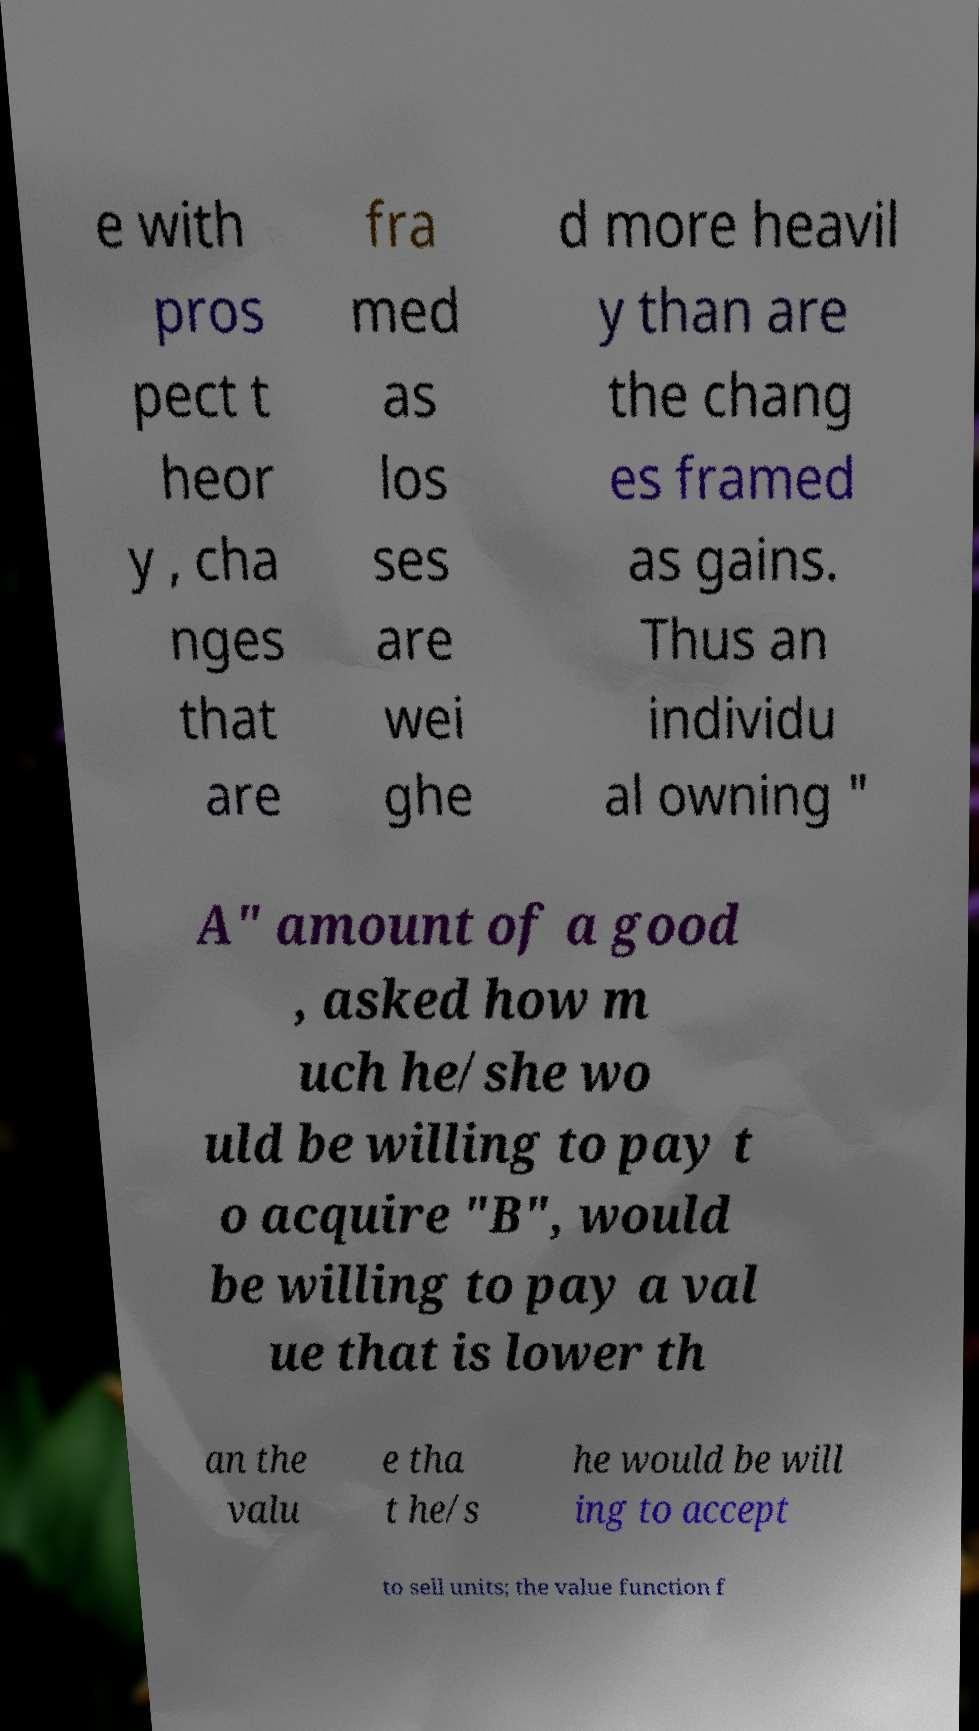I need the written content from this picture converted into text. Can you do that? e with pros pect t heor y , cha nges that are fra med as los ses are wei ghe d more heavil y than are the chang es framed as gains. Thus an individu al owning " A" amount of a good , asked how m uch he/she wo uld be willing to pay t o acquire "B", would be willing to pay a val ue that is lower th an the valu e tha t he/s he would be will ing to accept to sell units; the value function f 